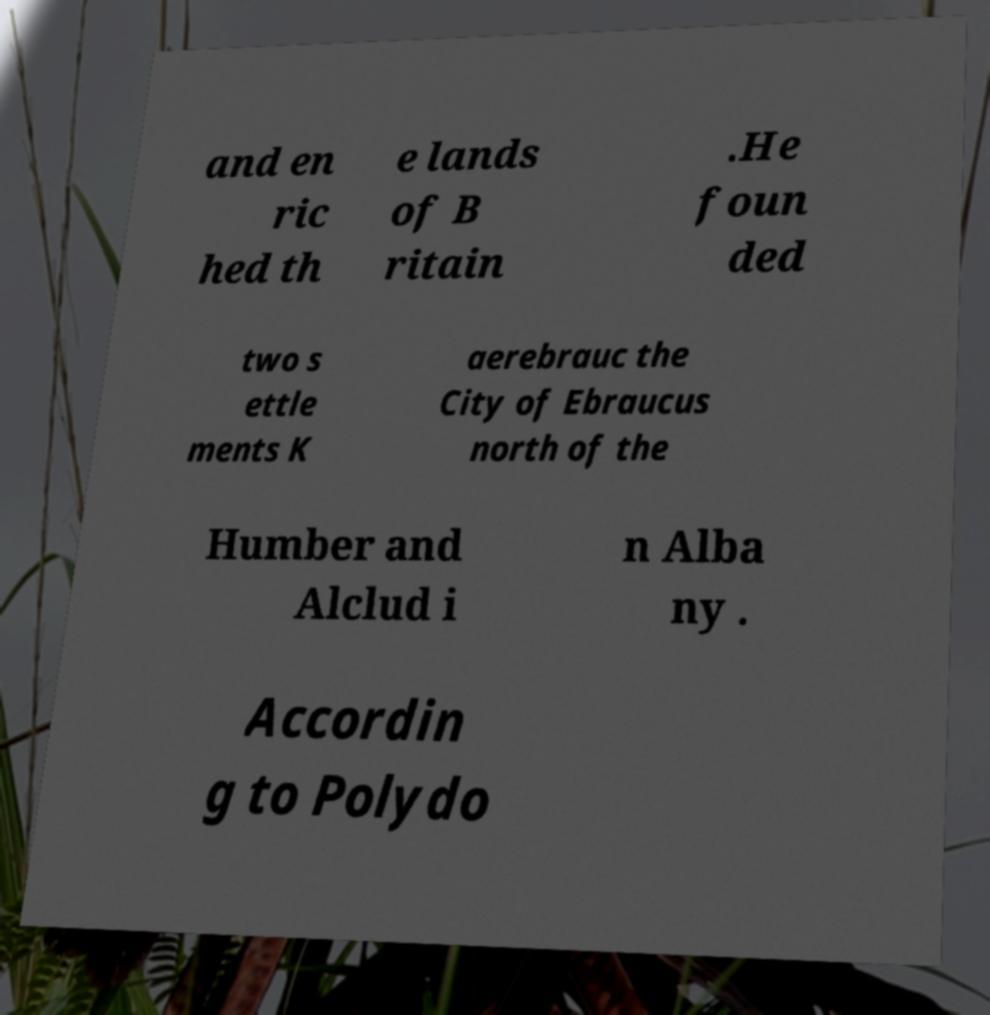What messages or text are displayed in this image? I need them in a readable, typed format. and en ric hed th e lands of B ritain .He foun ded two s ettle ments K aerebrauc the City of Ebraucus north of the Humber and Alclud i n Alba ny . Accordin g to Polydo 